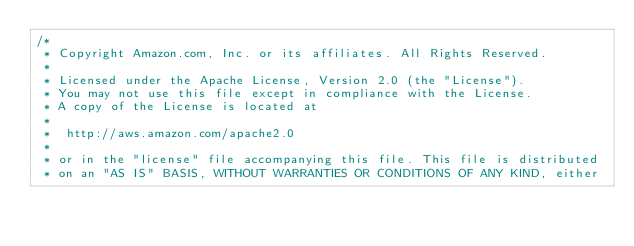<code> <loc_0><loc_0><loc_500><loc_500><_C#_>/*
 * Copyright Amazon.com, Inc. or its affiliates. All Rights Reserved.
 * 
 * Licensed under the Apache License, Version 2.0 (the "License").
 * You may not use this file except in compliance with the License.
 * A copy of the License is located at
 * 
 *  http://aws.amazon.com/apache2.0
 * 
 * or in the "license" file accompanying this file. This file is distributed
 * on an "AS IS" BASIS, WITHOUT WARRANTIES OR CONDITIONS OF ANY KIND, either</code> 